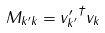<formula> <loc_0><loc_0><loc_500><loc_500>M _ { k ^ { \prime } k } = { v ^ { \prime } _ { k ^ { \prime } } } ^ { \dagger } v _ { k }</formula> 